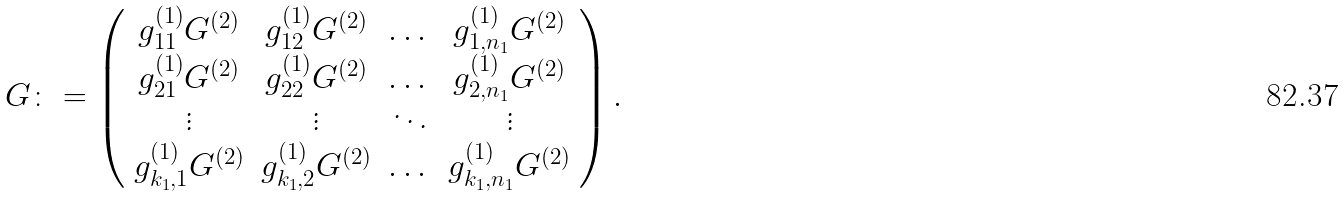<formula> <loc_0><loc_0><loc_500><loc_500>G \colon = \left ( \begin{array} { c c c c } g _ { 1 1 } ^ { ( 1 ) } G ^ { ( 2 ) } & g _ { 1 2 } ^ { ( 1 ) } G ^ { ( 2 ) } & \dots & g _ { 1 , n _ { 1 } } ^ { ( 1 ) } G ^ { ( 2 ) } \\ g _ { 2 1 } ^ { ( 1 ) } G ^ { ( 2 ) } & g _ { 2 2 } ^ { ( 1 ) } G ^ { ( 2 ) } & \dots & g _ { 2 , n _ { 1 } } ^ { ( 1 ) } G ^ { ( 2 ) } \\ \vdots & \vdots & \ddots & \vdots \\ g _ { k _ { 1 } , 1 } ^ { ( 1 ) } G ^ { ( 2 ) } & g _ { k _ { 1 } , 2 } ^ { ( 1 ) } G ^ { ( 2 ) } & \dots & g _ { k _ { 1 } , n _ { 1 } } ^ { ( 1 ) } G ^ { ( 2 ) } \\ \end{array} \right ) .</formula> 